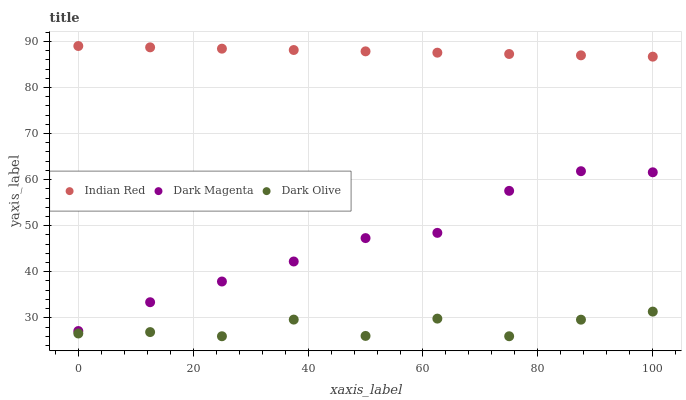Does Dark Olive have the minimum area under the curve?
Answer yes or no. Yes. Does Indian Red have the maximum area under the curve?
Answer yes or no. Yes. Does Dark Magenta have the minimum area under the curve?
Answer yes or no. No. Does Dark Magenta have the maximum area under the curve?
Answer yes or no. No. Is Indian Red the smoothest?
Answer yes or no. Yes. Is Dark Olive the roughest?
Answer yes or no. Yes. Is Dark Magenta the smoothest?
Answer yes or no. No. Is Dark Magenta the roughest?
Answer yes or no. No. Does Dark Olive have the lowest value?
Answer yes or no. Yes. Does Dark Magenta have the lowest value?
Answer yes or no. No. Does Indian Red have the highest value?
Answer yes or no. Yes. Does Dark Magenta have the highest value?
Answer yes or no. No. Is Dark Magenta less than Indian Red?
Answer yes or no. Yes. Is Indian Red greater than Dark Olive?
Answer yes or no. Yes. Does Dark Magenta intersect Indian Red?
Answer yes or no. No. 